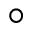Convert formula to latex. <formula><loc_0><loc_0><loc_500><loc_500>^ { \circ }</formula> 